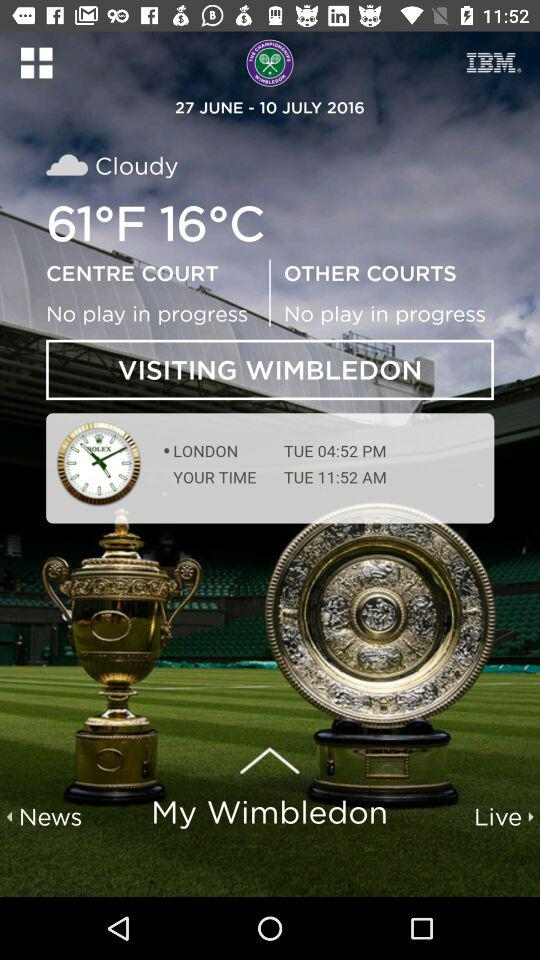What is the given date range? The given date range is from 27 JUNE to 10 JULY 2016. 